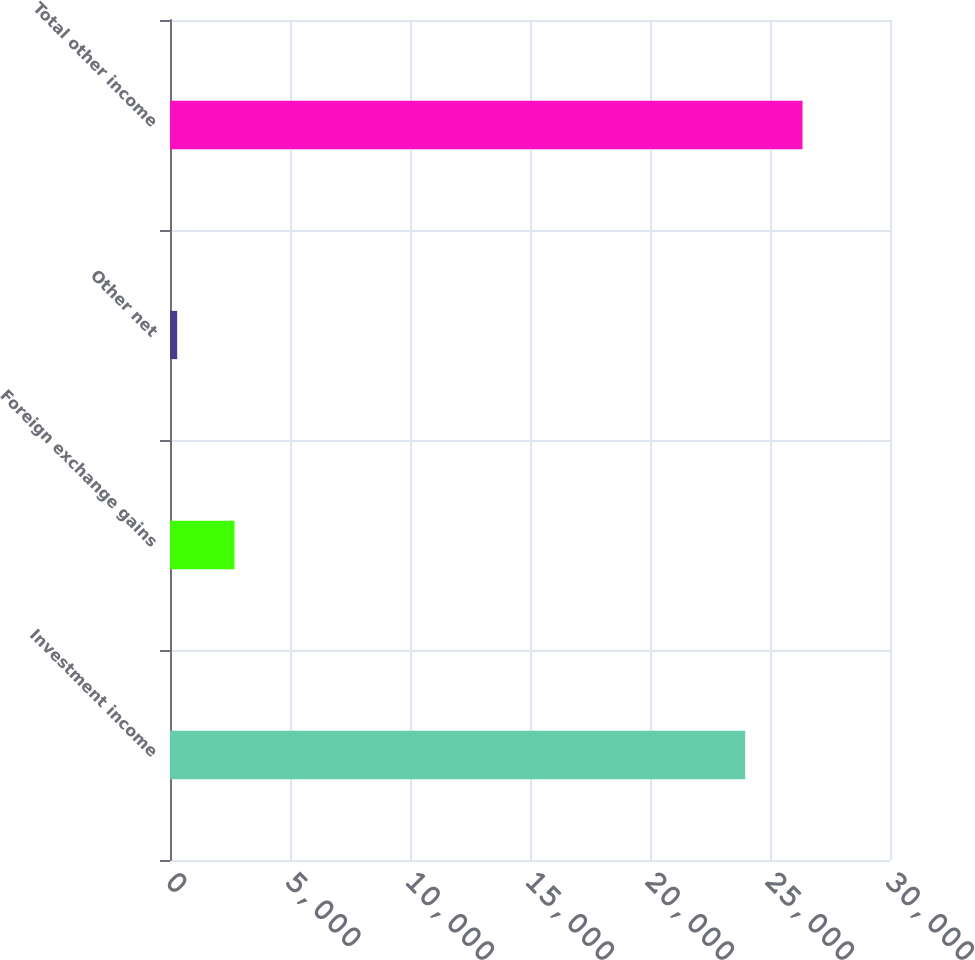Convert chart to OTSL. <chart><loc_0><loc_0><loc_500><loc_500><bar_chart><fcel>Investment income<fcel>Foreign exchange gains<fcel>Other net<fcel>Total other income<nl><fcel>23966<fcel>2688.1<fcel>299<fcel>26355.1<nl></chart> 